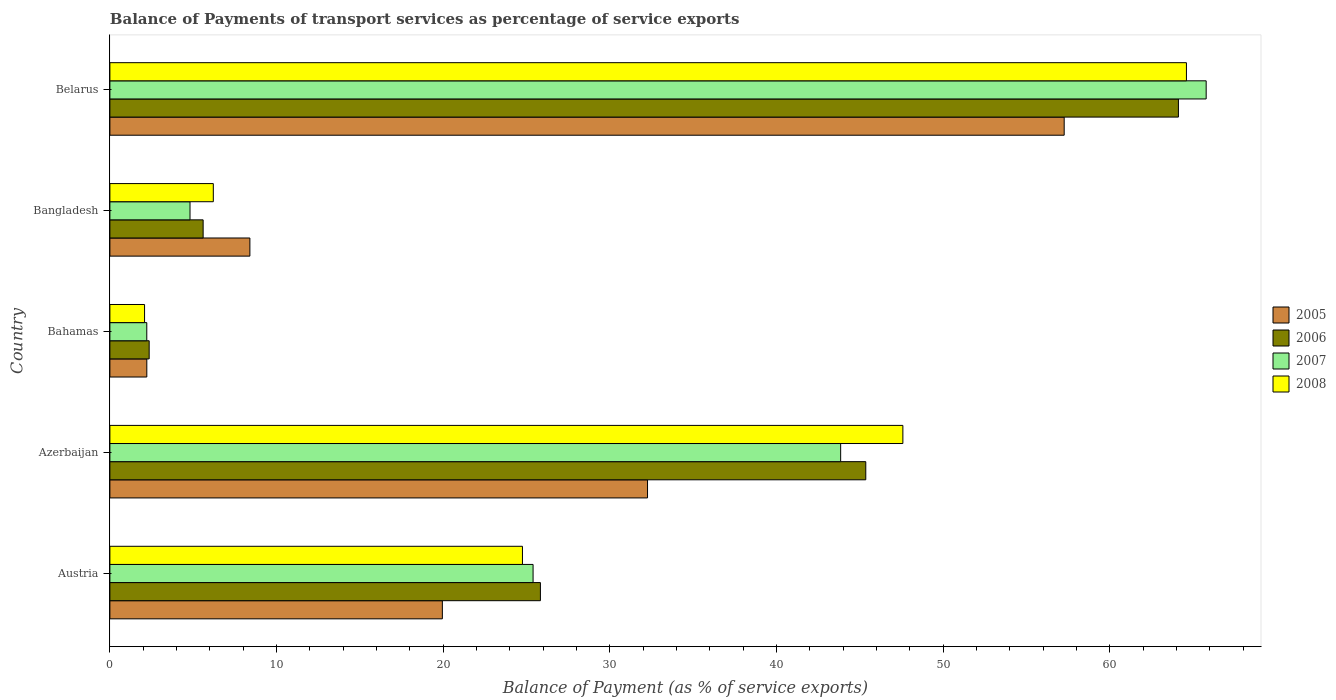How many groups of bars are there?
Keep it short and to the point. 5. Are the number of bars on each tick of the Y-axis equal?
Provide a short and direct response. Yes. What is the label of the 2nd group of bars from the top?
Your answer should be compact. Bangladesh. What is the balance of payments of transport services in 2005 in Austria?
Give a very brief answer. 19.95. Across all countries, what is the maximum balance of payments of transport services in 2008?
Keep it short and to the point. 64.6. Across all countries, what is the minimum balance of payments of transport services in 2005?
Provide a succinct answer. 2.22. In which country was the balance of payments of transport services in 2007 maximum?
Offer a terse response. Belarus. In which country was the balance of payments of transport services in 2005 minimum?
Keep it short and to the point. Bahamas. What is the total balance of payments of transport services in 2007 in the graph?
Make the answer very short. 142.04. What is the difference between the balance of payments of transport services in 2008 in Bahamas and that in Bangladesh?
Give a very brief answer. -4.12. What is the difference between the balance of payments of transport services in 2007 in Bangladesh and the balance of payments of transport services in 2006 in Azerbaijan?
Keep it short and to the point. -40.55. What is the average balance of payments of transport services in 2008 per country?
Give a very brief answer. 29.04. What is the difference between the balance of payments of transport services in 2008 and balance of payments of transport services in 2007 in Belarus?
Your answer should be very brief. -1.18. What is the ratio of the balance of payments of transport services in 2007 in Bahamas to that in Bangladesh?
Your answer should be compact. 0.46. Is the balance of payments of transport services in 2007 in Austria less than that in Belarus?
Give a very brief answer. Yes. Is the difference between the balance of payments of transport services in 2008 in Austria and Azerbaijan greater than the difference between the balance of payments of transport services in 2007 in Austria and Azerbaijan?
Offer a terse response. No. What is the difference between the highest and the second highest balance of payments of transport services in 2006?
Your answer should be compact. 18.76. What is the difference between the highest and the lowest balance of payments of transport services in 2008?
Make the answer very short. 62.51. In how many countries, is the balance of payments of transport services in 2005 greater than the average balance of payments of transport services in 2005 taken over all countries?
Make the answer very short. 2. Is it the case that in every country, the sum of the balance of payments of transport services in 2007 and balance of payments of transport services in 2006 is greater than the sum of balance of payments of transport services in 2008 and balance of payments of transport services in 2005?
Make the answer very short. No. What does the 3rd bar from the bottom in Azerbaijan represents?
Offer a very short reply. 2007. Is it the case that in every country, the sum of the balance of payments of transport services in 2006 and balance of payments of transport services in 2008 is greater than the balance of payments of transport services in 2007?
Provide a short and direct response. Yes. Are all the bars in the graph horizontal?
Provide a succinct answer. Yes. Are the values on the major ticks of X-axis written in scientific E-notation?
Offer a terse response. No. How are the legend labels stacked?
Give a very brief answer. Vertical. What is the title of the graph?
Keep it short and to the point. Balance of Payments of transport services as percentage of service exports. Does "1971" appear as one of the legend labels in the graph?
Offer a very short reply. No. What is the label or title of the X-axis?
Ensure brevity in your answer.  Balance of Payment (as % of service exports). What is the label or title of the Y-axis?
Offer a very short reply. Country. What is the Balance of Payment (as % of service exports) in 2005 in Austria?
Give a very brief answer. 19.95. What is the Balance of Payment (as % of service exports) of 2006 in Austria?
Your answer should be compact. 25.83. What is the Balance of Payment (as % of service exports) in 2007 in Austria?
Your response must be concise. 25.39. What is the Balance of Payment (as % of service exports) of 2008 in Austria?
Your response must be concise. 24.75. What is the Balance of Payment (as % of service exports) in 2005 in Azerbaijan?
Offer a terse response. 32.26. What is the Balance of Payment (as % of service exports) of 2006 in Azerbaijan?
Give a very brief answer. 45.35. What is the Balance of Payment (as % of service exports) in 2007 in Azerbaijan?
Give a very brief answer. 43.85. What is the Balance of Payment (as % of service exports) of 2008 in Azerbaijan?
Your response must be concise. 47.58. What is the Balance of Payment (as % of service exports) in 2005 in Bahamas?
Keep it short and to the point. 2.22. What is the Balance of Payment (as % of service exports) in 2006 in Bahamas?
Make the answer very short. 2.36. What is the Balance of Payment (as % of service exports) of 2007 in Bahamas?
Your answer should be compact. 2.21. What is the Balance of Payment (as % of service exports) in 2008 in Bahamas?
Provide a succinct answer. 2.08. What is the Balance of Payment (as % of service exports) in 2005 in Bangladesh?
Keep it short and to the point. 8.4. What is the Balance of Payment (as % of service exports) in 2006 in Bangladesh?
Provide a succinct answer. 5.6. What is the Balance of Payment (as % of service exports) in 2007 in Bangladesh?
Your answer should be compact. 4.81. What is the Balance of Payment (as % of service exports) in 2008 in Bangladesh?
Provide a succinct answer. 6.21. What is the Balance of Payment (as % of service exports) in 2005 in Belarus?
Provide a short and direct response. 57.26. What is the Balance of Payment (as % of service exports) in 2006 in Belarus?
Make the answer very short. 64.11. What is the Balance of Payment (as % of service exports) in 2007 in Belarus?
Offer a terse response. 65.78. What is the Balance of Payment (as % of service exports) in 2008 in Belarus?
Make the answer very short. 64.6. Across all countries, what is the maximum Balance of Payment (as % of service exports) of 2005?
Your answer should be very brief. 57.26. Across all countries, what is the maximum Balance of Payment (as % of service exports) of 2006?
Provide a short and direct response. 64.11. Across all countries, what is the maximum Balance of Payment (as % of service exports) in 2007?
Your answer should be very brief. 65.78. Across all countries, what is the maximum Balance of Payment (as % of service exports) of 2008?
Your response must be concise. 64.6. Across all countries, what is the minimum Balance of Payment (as % of service exports) of 2005?
Offer a terse response. 2.22. Across all countries, what is the minimum Balance of Payment (as % of service exports) in 2006?
Offer a very short reply. 2.36. Across all countries, what is the minimum Balance of Payment (as % of service exports) in 2007?
Provide a succinct answer. 2.21. Across all countries, what is the minimum Balance of Payment (as % of service exports) in 2008?
Make the answer very short. 2.08. What is the total Balance of Payment (as % of service exports) of 2005 in the graph?
Ensure brevity in your answer.  120.09. What is the total Balance of Payment (as % of service exports) of 2006 in the graph?
Offer a very short reply. 143.25. What is the total Balance of Payment (as % of service exports) in 2007 in the graph?
Give a very brief answer. 142.04. What is the total Balance of Payment (as % of service exports) in 2008 in the graph?
Offer a very short reply. 145.22. What is the difference between the Balance of Payment (as % of service exports) in 2005 in Austria and that in Azerbaijan?
Give a very brief answer. -12.31. What is the difference between the Balance of Payment (as % of service exports) in 2006 in Austria and that in Azerbaijan?
Ensure brevity in your answer.  -19.52. What is the difference between the Balance of Payment (as % of service exports) of 2007 in Austria and that in Azerbaijan?
Your answer should be very brief. -18.45. What is the difference between the Balance of Payment (as % of service exports) of 2008 in Austria and that in Azerbaijan?
Ensure brevity in your answer.  -22.83. What is the difference between the Balance of Payment (as % of service exports) of 2005 in Austria and that in Bahamas?
Give a very brief answer. 17.73. What is the difference between the Balance of Payment (as % of service exports) of 2006 in Austria and that in Bahamas?
Provide a succinct answer. 23.48. What is the difference between the Balance of Payment (as % of service exports) in 2007 in Austria and that in Bahamas?
Offer a very short reply. 23.18. What is the difference between the Balance of Payment (as % of service exports) of 2008 in Austria and that in Bahamas?
Your answer should be very brief. 22.67. What is the difference between the Balance of Payment (as % of service exports) in 2005 in Austria and that in Bangladesh?
Provide a succinct answer. 11.55. What is the difference between the Balance of Payment (as % of service exports) in 2006 in Austria and that in Bangladesh?
Offer a very short reply. 20.24. What is the difference between the Balance of Payment (as % of service exports) of 2007 in Austria and that in Bangladesh?
Keep it short and to the point. 20.58. What is the difference between the Balance of Payment (as % of service exports) of 2008 in Austria and that in Bangladesh?
Your answer should be compact. 18.55. What is the difference between the Balance of Payment (as % of service exports) of 2005 in Austria and that in Belarus?
Keep it short and to the point. -37.31. What is the difference between the Balance of Payment (as % of service exports) in 2006 in Austria and that in Belarus?
Your response must be concise. -38.28. What is the difference between the Balance of Payment (as % of service exports) in 2007 in Austria and that in Belarus?
Offer a very short reply. -40.39. What is the difference between the Balance of Payment (as % of service exports) in 2008 in Austria and that in Belarus?
Your response must be concise. -39.84. What is the difference between the Balance of Payment (as % of service exports) of 2005 in Azerbaijan and that in Bahamas?
Provide a short and direct response. 30.04. What is the difference between the Balance of Payment (as % of service exports) in 2006 in Azerbaijan and that in Bahamas?
Provide a succinct answer. 43. What is the difference between the Balance of Payment (as % of service exports) in 2007 in Azerbaijan and that in Bahamas?
Provide a short and direct response. 41.63. What is the difference between the Balance of Payment (as % of service exports) of 2008 in Azerbaijan and that in Bahamas?
Ensure brevity in your answer.  45.5. What is the difference between the Balance of Payment (as % of service exports) of 2005 in Azerbaijan and that in Bangladesh?
Provide a succinct answer. 23.86. What is the difference between the Balance of Payment (as % of service exports) in 2006 in Azerbaijan and that in Bangladesh?
Make the answer very short. 39.76. What is the difference between the Balance of Payment (as % of service exports) in 2007 in Azerbaijan and that in Bangladesh?
Your answer should be very brief. 39.04. What is the difference between the Balance of Payment (as % of service exports) of 2008 in Azerbaijan and that in Bangladesh?
Your response must be concise. 41.38. What is the difference between the Balance of Payment (as % of service exports) of 2005 in Azerbaijan and that in Belarus?
Keep it short and to the point. -25. What is the difference between the Balance of Payment (as % of service exports) in 2006 in Azerbaijan and that in Belarus?
Provide a succinct answer. -18.76. What is the difference between the Balance of Payment (as % of service exports) of 2007 in Azerbaijan and that in Belarus?
Ensure brevity in your answer.  -21.93. What is the difference between the Balance of Payment (as % of service exports) of 2008 in Azerbaijan and that in Belarus?
Your answer should be very brief. -17.01. What is the difference between the Balance of Payment (as % of service exports) in 2005 in Bahamas and that in Bangladesh?
Make the answer very short. -6.18. What is the difference between the Balance of Payment (as % of service exports) of 2006 in Bahamas and that in Bangladesh?
Provide a succinct answer. -3.24. What is the difference between the Balance of Payment (as % of service exports) of 2007 in Bahamas and that in Bangladesh?
Give a very brief answer. -2.59. What is the difference between the Balance of Payment (as % of service exports) of 2008 in Bahamas and that in Bangladesh?
Your answer should be compact. -4.12. What is the difference between the Balance of Payment (as % of service exports) of 2005 in Bahamas and that in Belarus?
Give a very brief answer. -55.04. What is the difference between the Balance of Payment (as % of service exports) in 2006 in Bahamas and that in Belarus?
Your response must be concise. -61.76. What is the difference between the Balance of Payment (as % of service exports) in 2007 in Bahamas and that in Belarus?
Offer a terse response. -63.57. What is the difference between the Balance of Payment (as % of service exports) of 2008 in Bahamas and that in Belarus?
Provide a succinct answer. -62.51. What is the difference between the Balance of Payment (as % of service exports) in 2005 in Bangladesh and that in Belarus?
Ensure brevity in your answer.  -48.86. What is the difference between the Balance of Payment (as % of service exports) of 2006 in Bangladesh and that in Belarus?
Your answer should be compact. -58.52. What is the difference between the Balance of Payment (as % of service exports) in 2007 in Bangladesh and that in Belarus?
Your answer should be very brief. -60.97. What is the difference between the Balance of Payment (as % of service exports) in 2008 in Bangladesh and that in Belarus?
Provide a short and direct response. -58.39. What is the difference between the Balance of Payment (as % of service exports) in 2005 in Austria and the Balance of Payment (as % of service exports) in 2006 in Azerbaijan?
Provide a short and direct response. -25.41. What is the difference between the Balance of Payment (as % of service exports) of 2005 in Austria and the Balance of Payment (as % of service exports) of 2007 in Azerbaijan?
Give a very brief answer. -23.9. What is the difference between the Balance of Payment (as % of service exports) of 2005 in Austria and the Balance of Payment (as % of service exports) of 2008 in Azerbaijan?
Your answer should be very brief. -27.63. What is the difference between the Balance of Payment (as % of service exports) in 2006 in Austria and the Balance of Payment (as % of service exports) in 2007 in Azerbaijan?
Ensure brevity in your answer.  -18.02. What is the difference between the Balance of Payment (as % of service exports) of 2006 in Austria and the Balance of Payment (as % of service exports) of 2008 in Azerbaijan?
Provide a succinct answer. -21.75. What is the difference between the Balance of Payment (as % of service exports) of 2007 in Austria and the Balance of Payment (as % of service exports) of 2008 in Azerbaijan?
Give a very brief answer. -22.19. What is the difference between the Balance of Payment (as % of service exports) in 2005 in Austria and the Balance of Payment (as % of service exports) in 2006 in Bahamas?
Offer a very short reply. 17.59. What is the difference between the Balance of Payment (as % of service exports) in 2005 in Austria and the Balance of Payment (as % of service exports) in 2007 in Bahamas?
Offer a terse response. 17.74. What is the difference between the Balance of Payment (as % of service exports) in 2005 in Austria and the Balance of Payment (as % of service exports) in 2008 in Bahamas?
Ensure brevity in your answer.  17.87. What is the difference between the Balance of Payment (as % of service exports) of 2006 in Austria and the Balance of Payment (as % of service exports) of 2007 in Bahamas?
Keep it short and to the point. 23.62. What is the difference between the Balance of Payment (as % of service exports) of 2006 in Austria and the Balance of Payment (as % of service exports) of 2008 in Bahamas?
Provide a succinct answer. 23.75. What is the difference between the Balance of Payment (as % of service exports) of 2007 in Austria and the Balance of Payment (as % of service exports) of 2008 in Bahamas?
Provide a succinct answer. 23.31. What is the difference between the Balance of Payment (as % of service exports) of 2005 in Austria and the Balance of Payment (as % of service exports) of 2006 in Bangladesh?
Your answer should be compact. 14.35. What is the difference between the Balance of Payment (as % of service exports) of 2005 in Austria and the Balance of Payment (as % of service exports) of 2007 in Bangladesh?
Make the answer very short. 15.14. What is the difference between the Balance of Payment (as % of service exports) of 2005 in Austria and the Balance of Payment (as % of service exports) of 2008 in Bangladesh?
Provide a short and direct response. 13.74. What is the difference between the Balance of Payment (as % of service exports) of 2006 in Austria and the Balance of Payment (as % of service exports) of 2007 in Bangladesh?
Provide a short and direct response. 21.02. What is the difference between the Balance of Payment (as % of service exports) in 2006 in Austria and the Balance of Payment (as % of service exports) in 2008 in Bangladesh?
Ensure brevity in your answer.  19.63. What is the difference between the Balance of Payment (as % of service exports) in 2007 in Austria and the Balance of Payment (as % of service exports) in 2008 in Bangladesh?
Provide a succinct answer. 19.19. What is the difference between the Balance of Payment (as % of service exports) in 2005 in Austria and the Balance of Payment (as % of service exports) in 2006 in Belarus?
Make the answer very short. -44.17. What is the difference between the Balance of Payment (as % of service exports) in 2005 in Austria and the Balance of Payment (as % of service exports) in 2007 in Belarus?
Give a very brief answer. -45.83. What is the difference between the Balance of Payment (as % of service exports) of 2005 in Austria and the Balance of Payment (as % of service exports) of 2008 in Belarus?
Make the answer very short. -44.65. What is the difference between the Balance of Payment (as % of service exports) in 2006 in Austria and the Balance of Payment (as % of service exports) in 2007 in Belarus?
Make the answer very short. -39.95. What is the difference between the Balance of Payment (as % of service exports) of 2006 in Austria and the Balance of Payment (as % of service exports) of 2008 in Belarus?
Make the answer very short. -38.76. What is the difference between the Balance of Payment (as % of service exports) of 2007 in Austria and the Balance of Payment (as % of service exports) of 2008 in Belarus?
Your response must be concise. -39.2. What is the difference between the Balance of Payment (as % of service exports) in 2005 in Azerbaijan and the Balance of Payment (as % of service exports) in 2006 in Bahamas?
Ensure brevity in your answer.  29.9. What is the difference between the Balance of Payment (as % of service exports) in 2005 in Azerbaijan and the Balance of Payment (as % of service exports) in 2007 in Bahamas?
Offer a very short reply. 30.05. What is the difference between the Balance of Payment (as % of service exports) in 2005 in Azerbaijan and the Balance of Payment (as % of service exports) in 2008 in Bahamas?
Keep it short and to the point. 30.18. What is the difference between the Balance of Payment (as % of service exports) in 2006 in Azerbaijan and the Balance of Payment (as % of service exports) in 2007 in Bahamas?
Make the answer very short. 43.14. What is the difference between the Balance of Payment (as % of service exports) in 2006 in Azerbaijan and the Balance of Payment (as % of service exports) in 2008 in Bahamas?
Your answer should be compact. 43.27. What is the difference between the Balance of Payment (as % of service exports) in 2007 in Azerbaijan and the Balance of Payment (as % of service exports) in 2008 in Bahamas?
Your response must be concise. 41.77. What is the difference between the Balance of Payment (as % of service exports) of 2005 in Azerbaijan and the Balance of Payment (as % of service exports) of 2006 in Bangladesh?
Provide a short and direct response. 26.66. What is the difference between the Balance of Payment (as % of service exports) in 2005 in Azerbaijan and the Balance of Payment (as % of service exports) in 2007 in Bangladesh?
Provide a succinct answer. 27.45. What is the difference between the Balance of Payment (as % of service exports) in 2005 in Azerbaijan and the Balance of Payment (as % of service exports) in 2008 in Bangladesh?
Provide a succinct answer. 26.06. What is the difference between the Balance of Payment (as % of service exports) of 2006 in Azerbaijan and the Balance of Payment (as % of service exports) of 2007 in Bangladesh?
Give a very brief answer. 40.55. What is the difference between the Balance of Payment (as % of service exports) in 2006 in Azerbaijan and the Balance of Payment (as % of service exports) in 2008 in Bangladesh?
Ensure brevity in your answer.  39.15. What is the difference between the Balance of Payment (as % of service exports) of 2007 in Azerbaijan and the Balance of Payment (as % of service exports) of 2008 in Bangladesh?
Make the answer very short. 37.64. What is the difference between the Balance of Payment (as % of service exports) of 2005 in Azerbaijan and the Balance of Payment (as % of service exports) of 2006 in Belarus?
Your response must be concise. -31.85. What is the difference between the Balance of Payment (as % of service exports) of 2005 in Azerbaijan and the Balance of Payment (as % of service exports) of 2007 in Belarus?
Give a very brief answer. -33.52. What is the difference between the Balance of Payment (as % of service exports) of 2005 in Azerbaijan and the Balance of Payment (as % of service exports) of 2008 in Belarus?
Offer a very short reply. -32.34. What is the difference between the Balance of Payment (as % of service exports) of 2006 in Azerbaijan and the Balance of Payment (as % of service exports) of 2007 in Belarus?
Offer a terse response. -20.43. What is the difference between the Balance of Payment (as % of service exports) of 2006 in Azerbaijan and the Balance of Payment (as % of service exports) of 2008 in Belarus?
Keep it short and to the point. -19.24. What is the difference between the Balance of Payment (as % of service exports) of 2007 in Azerbaijan and the Balance of Payment (as % of service exports) of 2008 in Belarus?
Your answer should be compact. -20.75. What is the difference between the Balance of Payment (as % of service exports) in 2005 in Bahamas and the Balance of Payment (as % of service exports) in 2006 in Bangladesh?
Offer a very short reply. -3.38. What is the difference between the Balance of Payment (as % of service exports) in 2005 in Bahamas and the Balance of Payment (as % of service exports) in 2007 in Bangladesh?
Keep it short and to the point. -2.59. What is the difference between the Balance of Payment (as % of service exports) of 2005 in Bahamas and the Balance of Payment (as % of service exports) of 2008 in Bangladesh?
Offer a very short reply. -3.99. What is the difference between the Balance of Payment (as % of service exports) of 2006 in Bahamas and the Balance of Payment (as % of service exports) of 2007 in Bangladesh?
Your answer should be compact. -2.45. What is the difference between the Balance of Payment (as % of service exports) in 2006 in Bahamas and the Balance of Payment (as % of service exports) in 2008 in Bangladesh?
Your answer should be very brief. -3.85. What is the difference between the Balance of Payment (as % of service exports) in 2007 in Bahamas and the Balance of Payment (as % of service exports) in 2008 in Bangladesh?
Keep it short and to the point. -3.99. What is the difference between the Balance of Payment (as % of service exports) in 2005 in Bahamas and the Balance of Payment (as % of service exports) in 2006 in Belarus?
Provide a short and direct response. -61.9. What is the difference between the Balance of Payment (as % of service exports) of 2005 in Bahamas and the Balance of Payment (as % of service exports) of 2007 in Belarus?
Ensure brevity in your answer.  -63.56. What is the difference between the Balance of Payment (as % of service exports) of 2005 in Bahamas and the Balance of Payment (as % of service exports) of 2008 in Belarus?
Keep it short and to the point. -62.38. What is the difference between the Balance of Payment (as % of service exports) of 2006 in Bahamas and the Balance of Payment (as % of service exports) of 2007 in Belarus?
Offer a very short reply. -63.42. What is the difference between the Balance of Payment (as % of service exports) of 2006 in Bahamas and the Balance of Payment (as % of service exports) of 2008 in Belarus?
Your response must be concise. -62.24. What is the difference between the Balance of Payment (as % of service exports) in 2007 in Bahamas and the Balance of Payment (as % of service exports) in 2008 in Belarus?
Keep it short and to the point. -62.38. What is the difference between the Balance of Payment (as % of service exports) of 2005 in Bangladesh and the Balance of Payment (as % of service exports) of 2006 in Belarus?
Keep it short and to the point. -55.71. What is the difference between the Balance of Payment (as % of service exports) in 2005 in Bangladesh and the Balance of Payment (as % of service exports) in 2007 in Belarus?
Offer a very short reply. -57.38. What is the difference between the Balance of Payment (as % of service exports) of 2005 in Bangladesh and the Balance of Payment (as % of service exports) of 2008 in Belarus?
Make the answer very short. -56.19. What is the difference between the Balance of Payment (as % of service exports) of 2006 in Bangladesh and the Balance of Payment (as % of service exports) of 2007 in Belarus?
Provide a succinct answer. -60.18. What is the difference between the Balance of Payment (as % of service exports) of 2006 in Bangladesh and the Balance of Payment (as % of service exports) of 2008 in Belarus?
Offer a terse response. -59. What is the difference between the Balance of Payment (as % of service exports) of 2007 in Bangladesh and the Balance of Payment (as % of service exports) of 2008 in Belarus?
Provide a short and direct response. -59.79. What is the average Balance of Payment (as % of service exports) of 2005 per country?
Your response must be concise. 24.02. What is the average Balance of Payment (as % of service exports) in 2006 per country?
Your response must be concise. 28.65. What is the average Balance of Payment (as % of service exports) of 2007 per country?
Offer a very short reply. 28.41. What is the average Balance of Payment (as % of service exports) of 2008 per country?
Give a very brief answer. 29.04. What is the difference between the Balance of Payment (as % of service exports) in 2005 and Balance of Payment (as % of service exports) in 2006 in Austria?
Provide a succinct answer. -5.88. What is the difference between the Balance of Payment (as % of service exports) of 2005 and Balance of Payment (as % of service exports) of 2007 in Austria?
Offer a very short reply. -5.44. What is the difference between the Balance of Payment (as % of service exports) of 2005 and Balance of Payment (as % of service exports) of 2008 in Austria?
Your answer should be very brief. -4.81. What is the difference between the Balance of Payment (as % of service exports) in 2006 and Balance of Payment (as % of service exports) in 2007 in Austria?
Keep it short and to the point. 0.44. What is the difference between the Balance of Payment (as % of service exports) of 2006 and Balance of Payment (as % of service exports) of 2008 in Austria?
Provide a succinct answer. 1.08. What is the difference between the Balance of Payment (as % of service exports) of 2007 and Balance of Payment (as % of service exports) of 2008 in Austria?
Your response must be concise. 0.64. What is the difference between the Balance of Payment (as % of service exports) of 2005 and Balance of Payment (as % of service exports) of 2006 in Azerbaijan?
Offer a very short reply. -13.09. What is the difference between the Balance of Payment (as % of service exports) in 2005 and Balance of Payment (as % of service exports) in 2007 in Azerbaijan?
Give a very brief answer. -11.59. What is the difference between the Balance of Payment (as % of service exports) in 2005 and Balance of Payment (as % of service exports) in 2008 in Azerbaijan?
Keep it short and to the point. -15.32. What is the difference between the Balance of Payment (as % of service exports) of 2006 and Balance of Payment (as % of service exports) of 2007 in Azerbaijan?
Your response must be concise. 1.51. What is the difference between the Balance of Payment (as % of service exports) of 2006 and Balance of Payment (as % of service exports) of 2008 in Azerbaijan?
Offer a terse response. -2.23. What is the difference between the Balance of Payment (as % of service exports) of 2007 and Balance of Payment (as % of service exports) of 2008 in Azerbaijan?
Your answer should be compact. -3.73. What is the difference between the Balance of Payment (as % of service exports) in 2005 and Balance of Payment (as % of service exports) in 2006 in Bahamas?
Your response must be concise. -0.14. What is the difference between the Balance of Payment (as % of service exports) of 2005 and Balance of Payment (as % of service exports) of 2007 in Bahamas?
Your answer should be very brief. 0. What is the difference between the Balance of Payment (as % of service exports) in 2005 and Balance of Payment (as % of service exports) in 2008 in Bahamas?
Offer a very short reply. 0.14. What is the difference between the Balance of Payment (as % of service exports) of 2006 and Balance of Payment (as % of service exports) of 2007 in Bahamas?
Ensure brevity in your answer.  0.14. What is the difference between the Balance of Payment (as % of service exports) in 2006 and Balance of Payment (as % of service exports) in 2008 in Bahamas?
Provide a succinct answer. 0.28. What is the difference between the Balance of Payment (as % of service exports) in 2007 and Balance of Payment (as % of service exports) in 2008 in Bahamas?
Your answer should be very brief. 0.13. What is the difference between the Balance of Payment (as % of service exports) of 2005 and Balance of Payment (as % of service exports) of 2006 in Bangladesh?
Provide a succinct answer. 2.81. What is the difference between the Balance of Payment (as % of service exports) in 2005 and Balance of Payment (as % of service exports) in 2007 in Bangladesh?
Offer a very short reply. 3.59. What is the difference between the Balance of Payment (as % of service exports) in 2005 and Balance of Payment (as % of service exports) in 2008 in Bangladesh?
Provide a succinct answer. 2.2. What is the difference between the Balance of Payment (as % of service exports) of 2006 and Balance of Payment (as % of service exports) of 2007 in Bangladesh?
Offer a very short reply. 0.79. What is the difference between the Balance of Payment (as % of service exports) in 2006 and Balance of Payment (as % of service exports) in 2008 in Bangladesh?
Your answer should be compact. -0.61. What is the difference between the Balance of Payment (as % of service exports) in 2007 and Balance of Payment (as % of service exports) in 2008 in Bangladesh?
Ensure brevity in your answer.  -1.4. What is the difference between the Balance of Payment (as % of service exports) of 2005 and Balance of Payment (as % of service exports) of 2006 in Belarus?
Your response must be concise. -6.85. What is the difference between the Balance of Payment (as % of service exports) of 2005 and Balance of Payment (as % of service exports) of 2007 in Belarus?
Offer a terse response. -8.52. What is the difference between the Balance of Payment (as % of service exports) in 2005 and Balance of Payment (as % of service exports) in 2008 in Belarus?
Provide a succinct answer. -7.34. What is the difference between the Balance of Payment (as % of service exports) in 2006 and Balance of Payment (as % of service exports) in 2007 in Belarus?
Provide a succinct answer. -1.67. What is the difference between the Balance of Payment (as % of service exports) of 2006 and Balance of Payment (as % of service exports) of 2008 in Belarus?
Your answer should be very brief. -0.48. What is the difference between the Balance of Payment (as % of service exports) in 2007 and Balance of Payment (as % of service exports) in 2008 in Belarus?
Your answer should be very brief. 1.18. What is the ratio of the Balance of Payment (as % of service exports) in 2005 in Austria to that in Azerbaijan?
Offer a very short reply. 0.62. What is the ratio of the Balance of Payment (as % of service exports) of 2006 in Austria to that in Azerbaijan?
Your response must be concise. 0.57. What is the ratio of the Balance of Payment (as % of service exports) of 2007 in Austria to that in Azerbaijan?
Make the answer very short. 0.58. What is the ratio of the Balance of Payment (as % of service exports) in 2008 in Austria to that in Azerbaijan?
Keep it short and to the point. 0.52. What is the ratio of the Balance of Payment (as % of service exports) of 2005 in Austria to that in Bahamas?
Ensure brevity in your answer.  9. What is the ratio of the Balance of Payment (as % of service exports) in 2006 in Austria to that in Bahamas?
Your response must be concise. 10.96. What is the ratio of the Balance of Payment (as % of service exports) of 2007 in Austria to that in Bahamas?
Offer a very short reply. 11.47. What is the ratio of the Balance of Payment (as % of service exports) of 2008 in Austria to that in Bahamas?
Offer a terse response. 11.9. What is the ratio of the Balance of Payment (as % of service exports) of 2005 in Austria to that in Bangladesh?
Provide a succinct answer. 2.37. What is the ratio of the Balance of Payment (as % of service exports) of 2006 in Austria to that in Bangladesh?
Offer a very short reply. 4.62. What is the ratio of the Balance of Payment (as % of service exports) in 2007 in Austria to that in Bangladesh?
Make the answer very short. 5.28. What is the ratio of the Balance of Payment (as % of service exports) in 2008 in Austria to that in Bangladesh?
Offer a very short reply. 3.99. What is the ratio of the Balance of Payment (as % of service exports) of 2005 in Austria to that in Belarus?
Your response must be concise. 0.35. What is the ratio of the Balance of Payment (as % of service exports) of 2006 in Austria to that in Belarus?
Your response must be concise. 0.4. What is the ratio of the Balance of Payment (as % of service exports) of 2007 in Austria to that in Belarus?
Provide a succinct answer. 0.39. What is the ratio of the Balance of Payment (as % of service exports) of 2008 in Austria to that in Belarus?
Your response must be concise. 0.38. What is the ratio of the Balance of Payment (as % of service exports) in 2005 in Azerbaijan to that in Bahamas?
Offer a terse response. 14.56. What is the ratio of the Balance of Payment (as % of service exports) of 2006 in Azerbaijan to that in Bahamas?
Offer a very short reply. 19.25. What is the ratio of the Balance of Payment (as % of service exports) of 2007 in Azerbaijan to that in Bahamas?
Your answer should be very brief. 19.81. What is the ratio of the Balance of Payment (as % of service exports) in 2008 in Azerbaijan to that in Bahamas?
Your answer should be compact. 22.87. What is the ratio of the Balance of Payment (as % of service exports) in 2005 in Azerbaijan to that in Bangladesh?
Provide a short and direct response. 3.84. What is the ratio of the Balance of Payment (as % of service exports) of 2006 in Azerbaijan to that in Bangladesh?
Keep it short and to the point. 8.11. What is the ratio of the Balance of Payment (as % of service exports) of 2007 in Azerbaijan to that in Bangladesh?
Make the answer very short. 9.12. What is the ratio of the Balance of Payment (as % of service exports) in 2008 in Azerbaijan to that in Bangladesh?
Your answer should be compact. 7.67. What is the ratio of the Balance of Payment (as % of service exports) in 2005 in Azerbaijan to that in Belarus?
Your response must be concise. 0.56. What is the ratio of the Balance of Payment (as % of service exports) in 2006 in Azerbaijan to that in Belarus?
Your response must be concise. 0.71. What is the ratio of the Balance of Payment (as % of service exports) of 2007 in Azerbaijan to that in Belarus?
Provide a succinct answer. 0.67. What is the ratio of the Balance of Payment (as % of service exports) of 2008 in Azerbaijan to that in Belarus?
Offer a terse response. 0.74. What is the ratio of the Balance of Payment (as % of service exports) of 2005 in Bahamas to that in Bangladesh?
Provide a short and direct response. 0.26. What is the ratio of the Balance of Payment (as % of service exports) of 2006 in Bahamas to that in Bangladesh?
Your answer should be very brief. 0.42. What is the ratio of the Balance of Payment (as % of service exports) in 2007 in Bahamas to that in Bangladesh?
Provide a short and direct response. 0.46. What is the ratio of the Balance of Payment (as % of service exports) of 2008 in Bahamas to that in Bangladesh?
Give a very brief answer. 0.34. What is the ratio of the Balance of Payment (as % of service exports) of 2005 in Bahamas to that in Belarus?
Offer a very short reply. 0.04. What is the ratio of the Balance of Payment (as % of service exports) in 2006 in Bahamas to that in Belarus?
Provide a succinct answer. 0.04. What is the ratio of the Balance of Payment (as % of service exports) in 2007 in Bahamas to that in Belarus?
Give a very brief answer. 0.03. What is the ratio of the Balance of Payment (as % of service exports) of 2008 in Bahamas to that in Belarus?
Offer a terse response. 0.03. What is the ratio of the Balance of Payment (as % of service exports) of 2005 in Bangladesh to that in Belarus?
Provide a succinct answer. 0.15. What is the ratio of the Balance of Payment (as % of service exports) in 2006 in Bangladesh to that in Belarus?
Keep it short and to the point. 0.09. What is the ratio of the Balance of Payment (as % of service exports) in 2007 in Bangladesh to that in Belarus?
Ensure brevity in your answer.  0.07. What is the ratio of the Balance of Payment (as % of service exports) in 2008 in Bangladesh to that in Belarus?
Offer a terse response. 0.1. What is the difference between the highest and the second highest Balance of Payment (as % of service exports) in 2005?
Your response must be concise. 25. What is the difference between the highest and the second highest Balance of Payment (as % of service exports) of 2006?
Make the answer very short. 18.76. What is the difference between the highest and the second highest Balance of Payment (as % of service exports) in 2007?
Offer a terse response. 21.93. What is the difference between the highest and the second highest Balance of Payment (as % of service exports) in 2008?
Offer a terse response. 17.01. What is the difference between the highest and the lowest Balance of Payment (as % of service exports) of 2005?
Provide a succinct answer. 55.04. What is the difference between the highest and the lowest Balance of Payment (as % of service exports) in 2006?
Offer a terse response. 61.76. What is the difference between the highest and the lowest Balance of Payment (as % of service exports) in 2007?
Ensure brevity in your answer.  63.57. What is the difference between the highest and the lowest Balance of Payment (as % of service exports) in 2008?
Give a very brief answer. 62.51. 